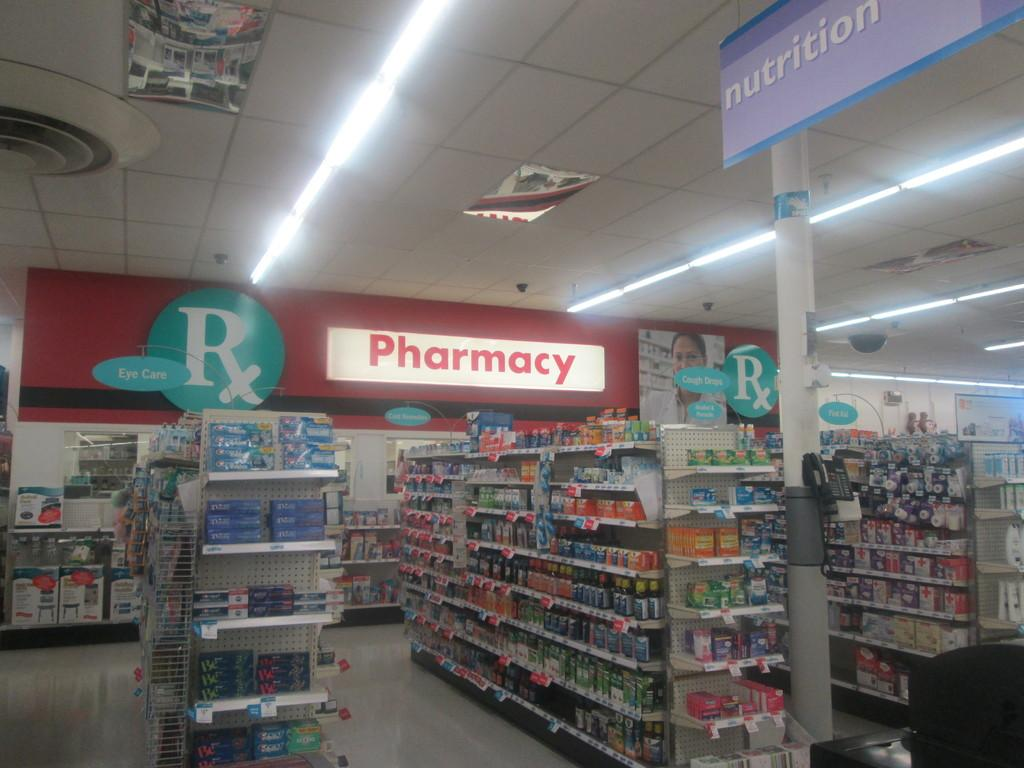<image>
Provide a brief description of the given image. Giant Pharmacy sign in the back of a department store. 